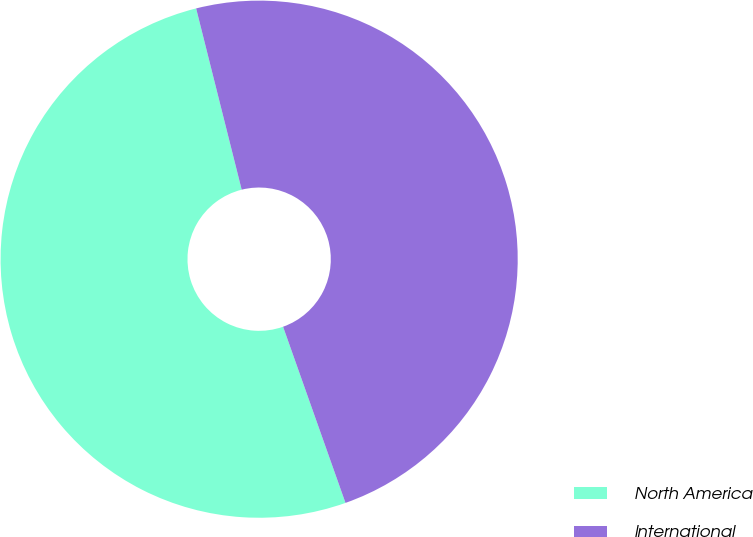Convert chart to OTSL. <chart><loc_0><loc_0><loc_500><loc_500><pie_chart><fcel>North America<fcel>International<nl><fcel>51.5%<fcel>48.5%<nl></chart> 